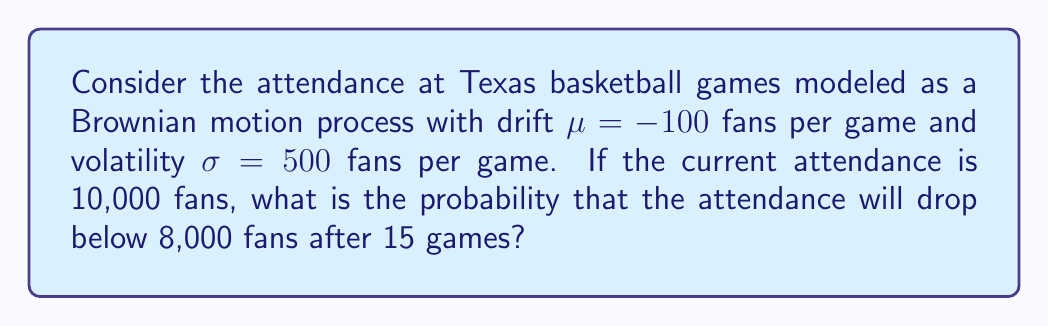Give your solution to this math problem. Let's approach this step-by-step:

1) In a Brownian motion process, the change in attendance (X) follows a normal distribution:

   $X \sim N(\mu t, \sigma^2 t)$

   where $t$ is the number of games.

2) We're looking for $P(X < -2000)$ after 15 games, as the attendance needs to drop by more than 2000 to go below 8000.

3) For $t = 15$, the mean and variance of X are:

   $E[X] = \mu t = -100 * 15 = -1500$
   $Var(X) = \sigma^2 t = 500^2 * 15 = 3,750,000$

4) To standardize this, we calculate the z-score:

   $z = \frac{-2000 - (-1500)}{\sqrt{3,750,000}} = \frac{-500}{1936.49} = -0.258$

5) The probability is then:

   $P(X < -2000) = P(Z < -0.258)$

6) Using a standard normal table or calculator, we find:

   $P(Z < -0.258) \approx 0.3981$

Therefore, the probability of attendance dropping below 8,000 fans after 15 games is approximately 0.3981 or 39.81%.
Answer: 0.3981 